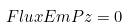Convert formula to latex. <formula><loc_0><loc_0><loc_500><loc_500>\ F l u x E m P z = 0</formula> 